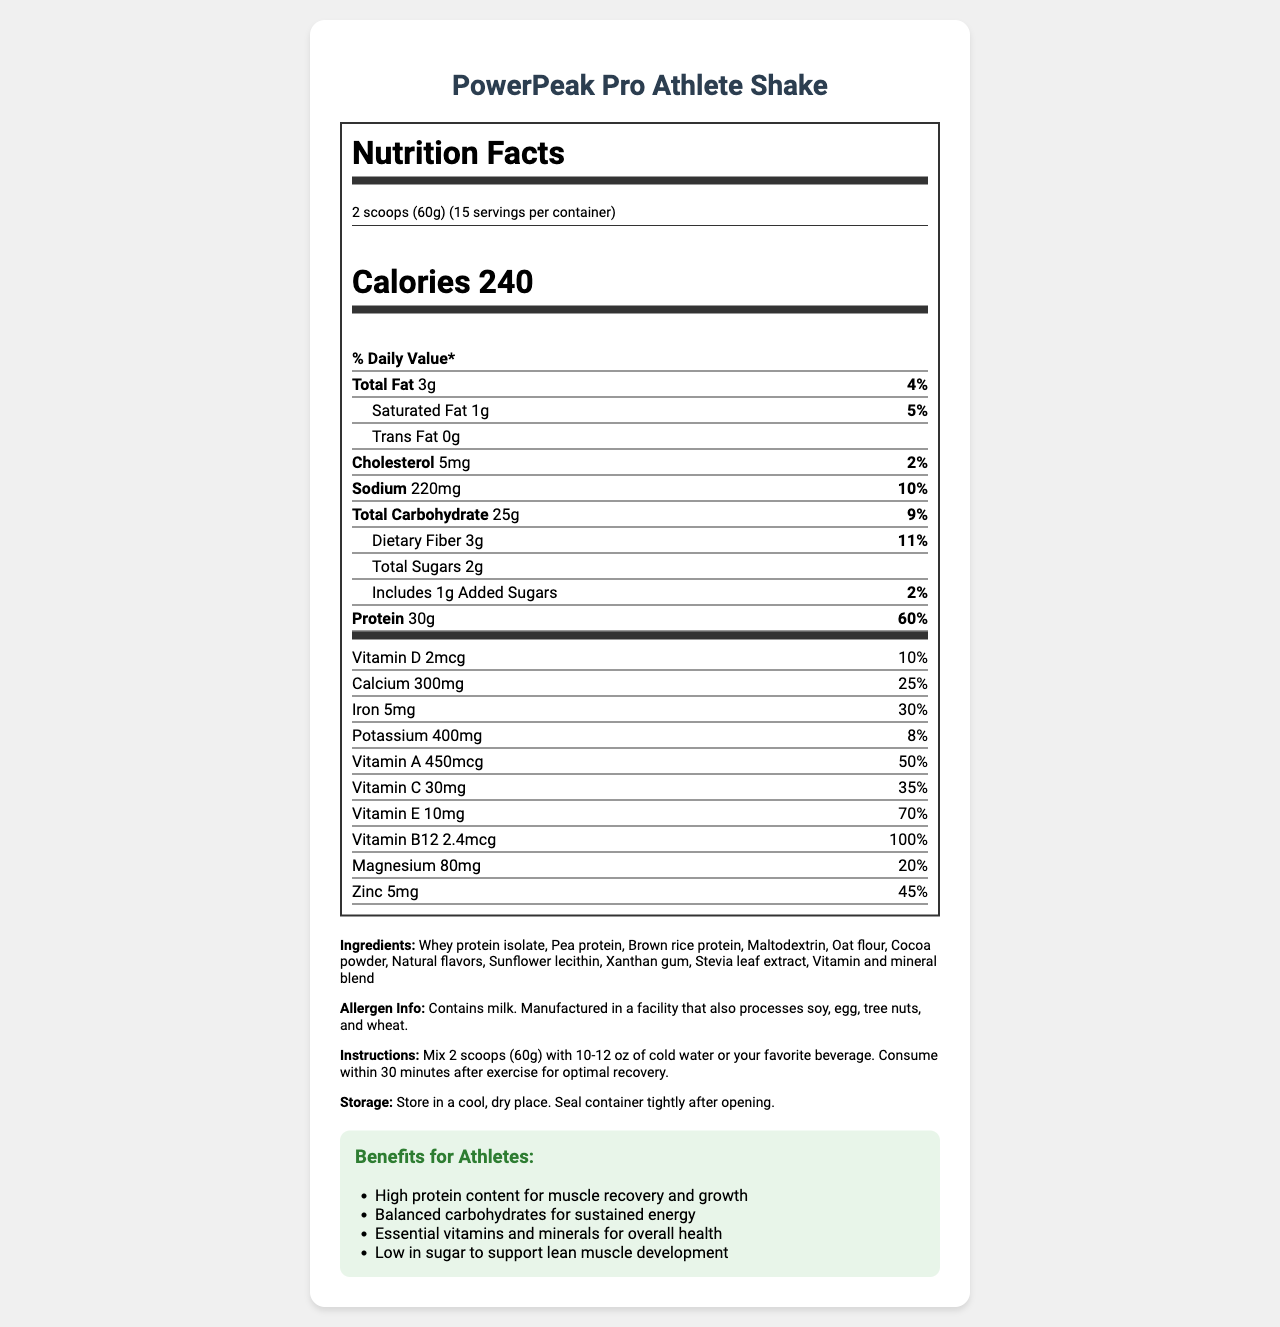what is the serving size of the PowerPeak Pro Athlete Shake? The serving size is mentioned at the top of the nutrition label in the document.
Answer: 2 scoops (60g) how many servings are there per container? This information is located in the serving information section of the nutrition label.
Answer: 15 how many grams of protein are in one serving? The amount of protein is listed in the nutrient section of the document.
Answer: 30g what is the daily value percentage of vitamin B12 in one serving? The daily value percentage for vitamin B12 is specified in the vitamins section of the document.
Answer: 100% how many added sugars are in one serving of the shake? The amount of added sugars can be found in the nutrient section under total sugars.
Answer: 1g what is the total calorie count per serving? A. 200 B. 220 C. 240 The calories per serving are highlighted prominently in the nutrition label section.
Answer: C. 240 what is the highest daily value percentage among the vitamins and minerals listed? A. Vitamin A B. Iron C. Magnesium D. Vitamin B12 The daily value of vitamin B12 is 100%, which is the highest among the listed vitamins and minerals.
Answer: D. Vitamin B12 which of the following ingredients in the product does NOT contain protein? A. Whey protein isolate B. Pea protein C. Brown rice protein D. Maltodextrin Maltodextrin is a carbohydrate and does not contain any protein.
Answer: D. Maltodextrin does this product contain any trans fat? The nutrition facts label explicitly states that there are 0g of trans fat in one serving.
Answer: no is the PowerPeak Pro Athlete Shake designed for competitive athletes? The target audience mentioned in the document indicates that it is designed for competitive athletes.
Answer: yes summarize the main benefits of the PowerPeak Pro Athlete Shake. The benefits for athletes section clearly lists these four benefits, making them the main advantages of this product.
Answer: The PowerPeak Pro Athlete Shake is designed to support muscle recovery and growth due to its high protein content. It provides balanced carbohydrates for sustained energy, essential vitamins and minerals for overall health, and is low in sugar to support lean muscle development. is this product allergen-free? The allergen information specifies that it contains milk and is manufactured in a facility that processes soy, egg, tree nuts, and wheat.
Answer: no what are the main sources of protein in the PowerPeak Pro Athlete Shake? The ingredients list these three components as the main sources of protein.
Answer: Whey protein isolate, Pea protein, Brown rice protein how much dietary fiber is there per serving? The amount of dietary fiber per serving is listed in the nutrient section under total carbohydrate.
Answer: 3g what is suggested mix ratio for the shake? This recommendation is provided in the instructions section of the document.
Answer: Mix 2 scoops (60g) with 10-12 oz of cold water or your favorite beverage. what is the main idea of the entire document? The document details the serving size, nutritional content, ingredients, allergen information, instructions on usage, storage, and the benefits aimed at enhancing athletic performance and recovery.
Answer: The PowerPeak Pro Athlete Shake is a high-protein, low-sugar meal replacement shake designed for competitive athletes to aid in muscle recovery and overall health. It provides a balanced mix of macronutrients, vitamins, and minerals, with specific instructions on how to use it for optimal recovery. does the product container need to be refrigerated after opening? The storage information only instructs to store in a cool, dry place, not requiring refrigeration.
Answer: no how much vitamin C is included in one serving? The document lists the amount of vitamin C in the vitamins section.
Answer: 30mg what additional information is needed to determine if the shake is keto-friendly? To determine if the shake is keto-friendly, we need the specific breakdown of net carbs, which is not provided in the document.
Answer: Not enough information 